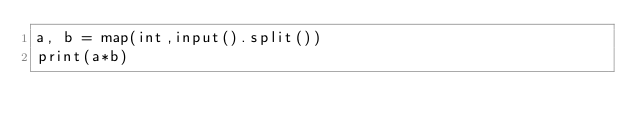Convert code to text. <code><loc_0><loc_0><loc_500><loc_500><_Python_>a, b = map(int,input().split())
print(a*b)

</code> 